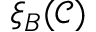<formula> <loc_0><loc_0><loc_500><loc_500>\xi _ { B } ( \mathcal { C } )</formula> 